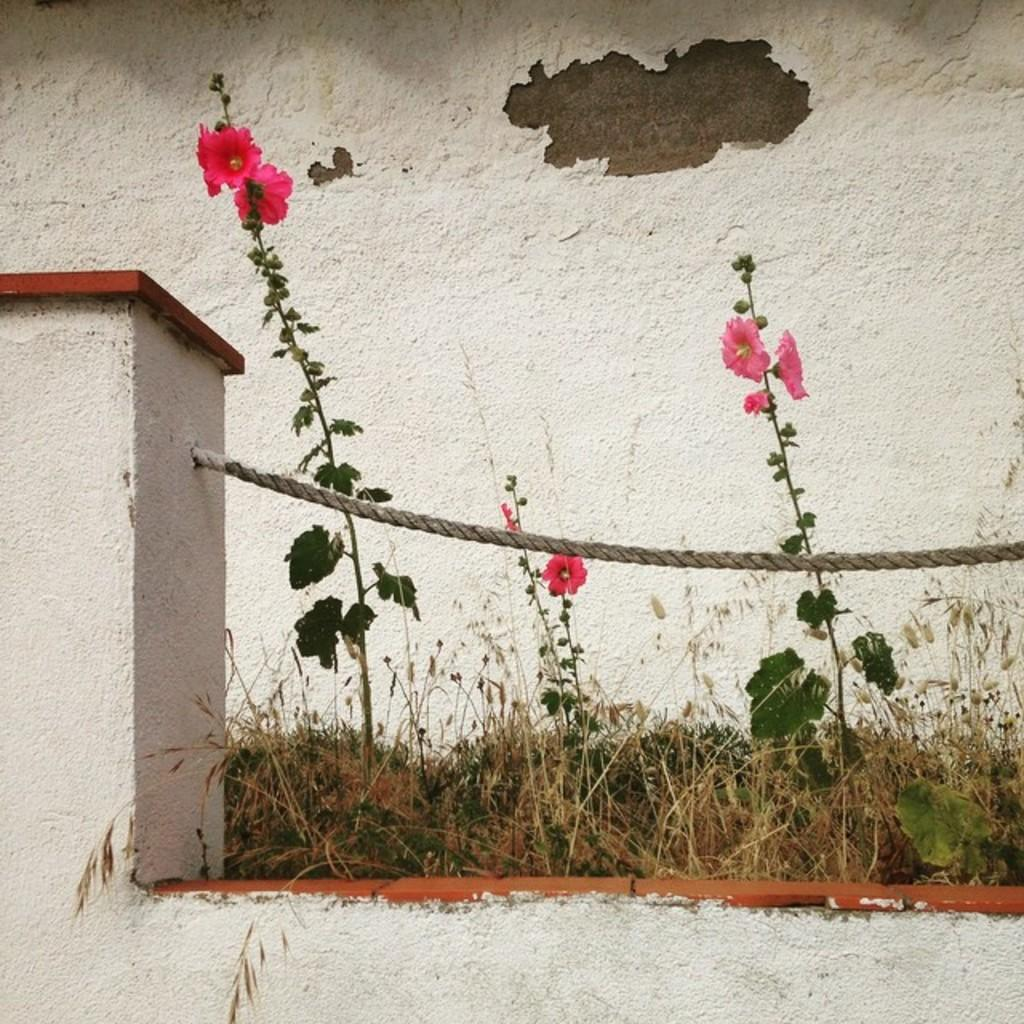What types of flowers can be seen in the image? There are red and pink color flowers in the image. What else is present in the image besides flowers? There are plants, a white wall, a pillar, a rope, and dry grass in the image. Can you describe the color of the wall in the image? The wall in the image is white. What is the material of the pillar in the image? The material of the pillar is not specified in the image. What happens when the rope bursts in the image? There is no rope bursting in the image; it is not depicted as being under any tension or stress. 